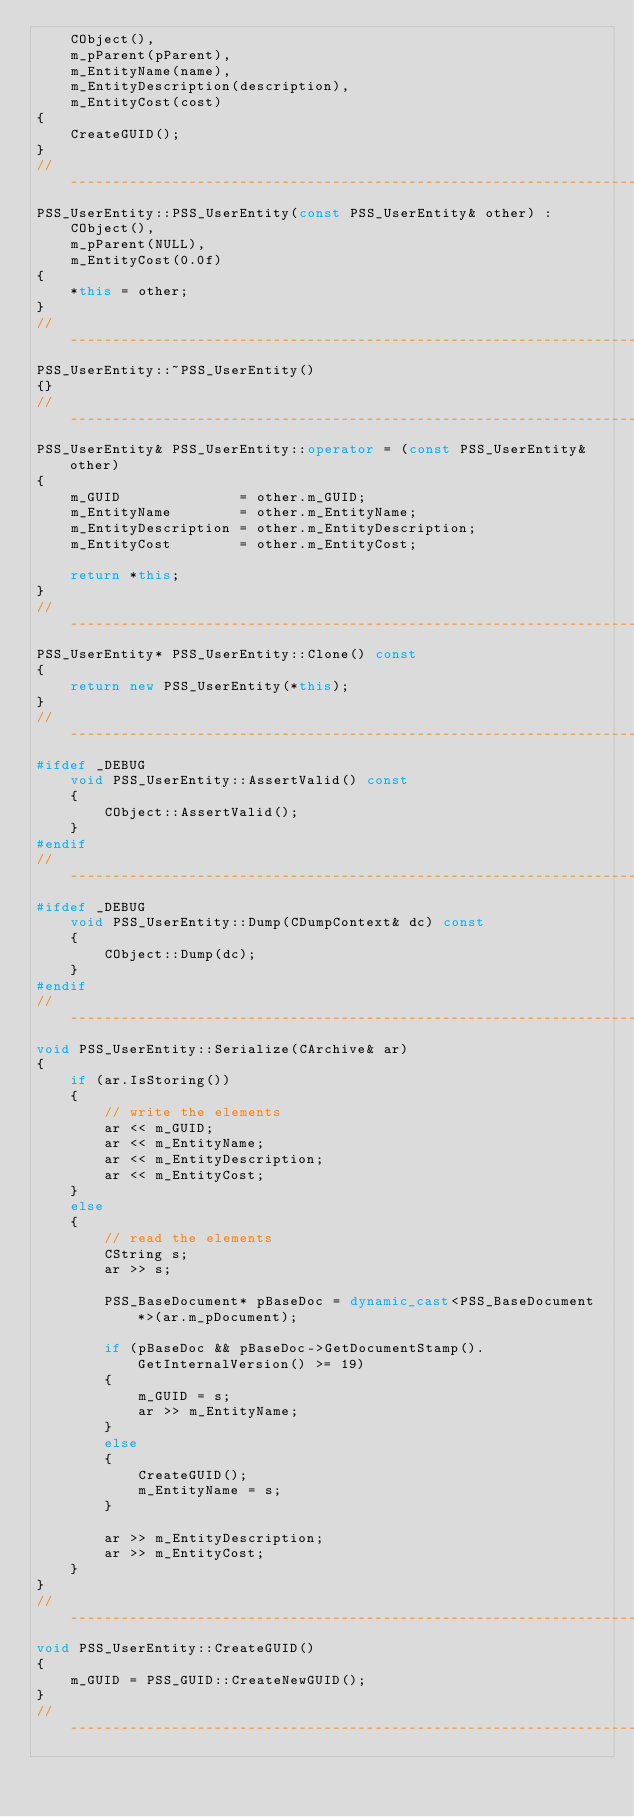Convert code to text. <code><loc_0><loc_0><loc_500><loc_500><_C++_>    CObject(),
    m_pParent(pParent),
    m_EntityName(name),
    m_EntityDescription(description),
    m_EntityCost(cost)
{
    CreateGUID();
}
//---------------------------------------------------------------------------
PSS_UserEntity::PSS_UserEntity(const PSS_UserEntity& other) :
    CObject(),
    m_pParent(NULL),
    m_EntityCost(0.0f)
{
    *this = other;
}
//---------------------------------------------------------------------------
PSS_UserEntity::~PSS_UserEntity()
{}
//---------------------------------------------------------------------------
PSS_UserEntity& PSS_UserEntity::operator = (const PSS_UserEntity& other)
{
    m_GUID              = other.m_GUID;
    m_EntityName        = other.m_EntityName;
    m_EntityDescription = other.m_EntityDescription;
    m_EntityCost        = other.m_EntityCost;

    return *this;
}
//---------------------------------------------------------------------------
PSS_UserEntity* PSS_UserEntity::Clone() const
{
    return new PSS_UserEntity(*this);
}
//---------------------------------------------------------------------------
#ifdef _DEBUG
    void PSS_UserEntity::AssertValid() const
    {
        CObject::AssertValid();
    }
#endif
//---------------------------------------------------------------------------
#ifdef _DEBUG
    void PSS_UserEntity::Dump(CDumpContext& dc) const
    {
        CObject::Dump(dc);
    }
#endif
//---------------------------------------------------------------------------
void PSS_UserEntity::Serialize(CArchive& ar)
{
    if (ar.IsStoring())
    {
        // write the elements
        ar << m_GUID;
        ar << m_EntityName;
        ar << m_EntityDescription;
        ar << m_EntityCost;
    }
    else
    {
        // read the elements
        CString s;
        ar >> s;

        PSS_BaseDocument* pBaseDoc = dynamic_cast<PSS_BaseDocument*>(ar.m_pDocument);

        if (pBaseDoc && pBaseDoc->GetDocumentStamp().GetInternalVersion() >= 19)
        {
            m_GUID = s;
            ar >> m_EntityName;
        }
        else
        {
            CreateGUID();
            m_EntityName = s;
        }

        ar >> m_EntityDescription;
        ar >> m_EntityCost;
    }
}
//---------------------------------------------------------------------------
void PSS_UserEntity::CreateGUID()
{
    m_GUID = PSS_GUID::CreateNewGUID();
}
//---------------------------------------------------------------------------
</code> 